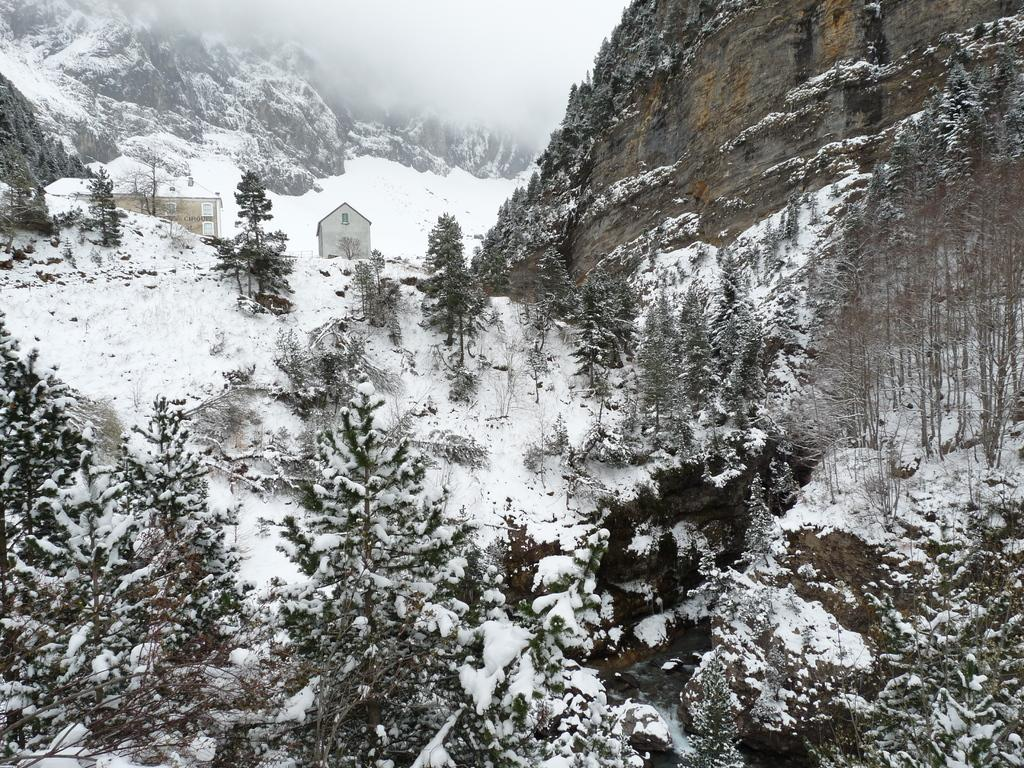What type of natural formation can be seen in the image? There are mountains in the image. What is present on the mountains? There are trees and houses on the mountains. What is the weather like in the image? There is snow on the trees and mountains, indicating a cold climate. How many cakes are being used to decorate the trees in the image? There are no cakes present in the image; the trees are covered in snow. What type of bead is being used to create the snow effect on the mountains? There is no bead used to create the snow effect in the image; the snow is naturally occurring. 